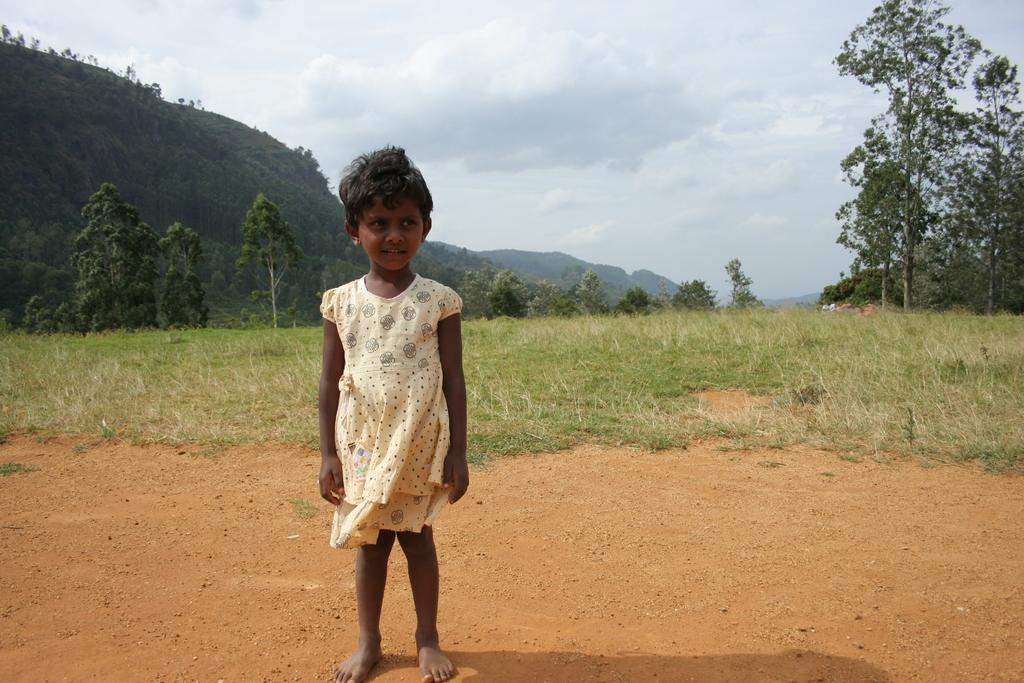What is the main subject of the image? There is a girl child in the image. Where is the girl child standing? The girl child is standing on a mud path. What type of surface is behind the girl child? There is a grass surface behind the girl child. What can be seen in the distance in the image? Trees and hills are visible in the distance. What is visible in the sky in the image? The sky is visible with clouds. What type of bait is the girl child using to catch fish in the image? There is no indication in the image that the girl child is fishing or using bait. What color is the girl child's dress in the image? The provided facts do not mention the color of the girl child's dress. 